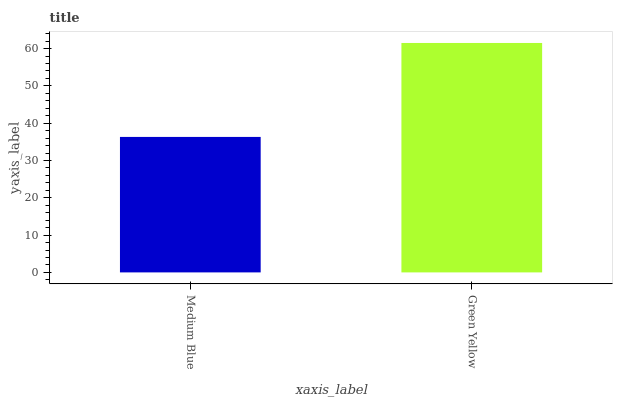Is Green Yellow the minimum?
Answer yes or no. No. Is Green Yellow greater than Medium Blue?
Answer yes or no. Yes. Is Medium Blue less than Green Yellow?
Answer yes or no. Yes. Is Medium Blue greater than Green Yellow?
Answer yes or no. No. Is Green Yellow less than Medium Blue?
Answer yes or no. No. Is Green Yellow the high median?
Answer yes or no. Yes. Is Medium Blue the low median?
Answer yes or no. Yes. Is Medium Blue the high median?
Answer yes or no. No. Is Green Yellow the low median?
Answer yes or no. No. 